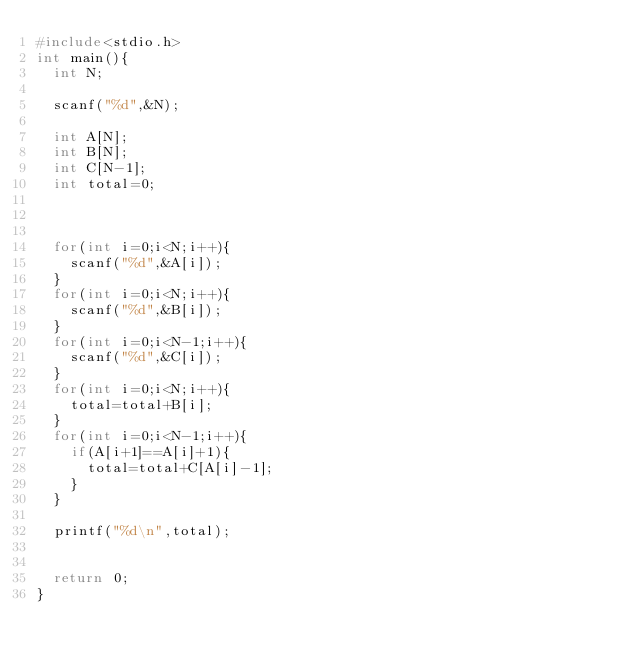Convert code to text. <code><loc_0><loc_0><loc_500><loc_500><_C_>#include<stdio.h>
int main(){
  int N;
  
  scanf("%d",&N);
  
  int A[N];
  int B[N];
  int C[N-1];
  int total=0;
  
    
  
  for(int i=0;i<N;i++){
    scanf("%d",&A[i]);
  }
  for(int i=0;i<N;i++){
    scanf("%d",&B[i]);
  }
  for(int i=0;i<N-1;i++){
    scanf("%d",&C[i]);
  }
  for(int i=0;i<N;i++){
    total=total+B[i];
  }
  for(int i=0;i<N-1;i++){
    if(A[i+1]==A[i]+1){
      total=total+C[A[i]-1];
    }
  }
  
  printf("%d\n",total);
  
  
  return 0;
}

</code> 